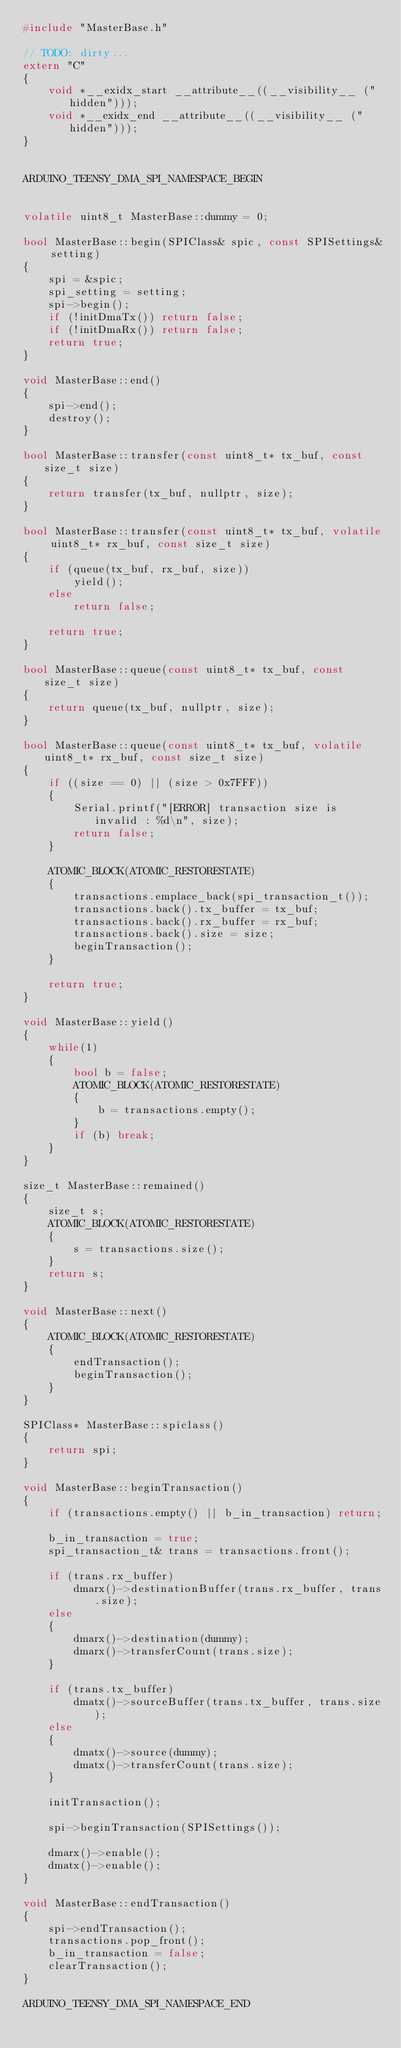Convert code to text. <code><loc_0><loc_0><loc_500><loc_500><_C++_>#include "MasterBase.h"

// TODO: dirty...
extern "C"
{
    void *__exidx_start __attribute__((__visibility__ ("hidden")));
    void *__exidx_end __attribute__((__visibility__ ("hidden")));
}


ARDUINO_TEENSY_DMA_SPI_NAMESPACE_BEGIN


volatile uint8_t MasterBase::dummy = 0;

bool MasterBase::begin(SPIClass& spic, const SPISettings& setting)
{
    spi = &spic;
    spi_setting = setting;
    spi->begin();
    if (!initDmaTx()) return false;
    if (!initDmaRx()) return false;
    return true;
}

void MasterBase::end()
{
    spi->end();
    destroy();
}

bool MasterBase::transfer(const uint8_t* tx_buf, const size_t size)
{
    return transfer(tx_buf, nullptr, size);
}

bool MasterBase::transfer(const uint8_t* tx_buf, volatile uint8_t* rx_buf, const size_t size)
{
    if (queue(tx_buf, rx_buf, size))
        yield();
    else
        return false;

    return true;
}

bool MasterBase::queue(const uint8_t* tx_buf, const size_t size)
{
    return queue(tx_buf, nullptr, size);
}

bool MasterBase::queue(const uint8_t* tx_buf, volatile uint8_t* rx_buf, const size_t size)
{
    if ((size == 0) || (size > 0x7FFF))
    {
        Serial.printf("[ERROR] transaction size is invalid : %d\n", size);
        return false;
    }

    ATOMIC_BLOCK(ATOMIC_RESTORESTATE)
    {
        transactions.emplace_back(spi_transaction_t());
        transactions.back().tx_buffer = tx_buf;
        transactions.back().rx_buffer = rx_buf;
        transactions.back().size = size;
        beginTransaction();
    }

    return true;
}

void MasterBase::yield()
{
    while(1)
    {
        bool b = false;
        ATOMIC_BLOCK(ATOMIC_RESTORESTATE)
        {
            b = transactions.empty();
        }
        if (b) break;
    }
}

size_t MasterBase::remained()
{
    size_t s;
    ATOMIC_BLOCK(ATOMIC_RESTORESTATE)
    {
        s = transactions.size();
    }
    return s;
}

void MasterBase::next()
{
    ATOMIC_BLOCK(ATOMIC_RESTORESTATE)
    {
        endTransaction();
        beginTransaction();
    }
}

SPIClass* MasterBase::spiclass()
{
    return spi;
}

void MasterBase::beginTransaction()
{
    if (transactions.empty() || b_in_transaction) return;

    b_in_transaction = true;
    spi_transaction_t& trans = transactions.front();

    if (trans.rx_buffer)
        dmarx()->destinationBuffer(trans.rx_buffer, trans.size);
    else
    {
        dmarx()->destination(dummy);
        dmarx()->transferCount(trans.size);
    }

    if (trans.tx_buffer)
        dmatx()->sourceBuffer(trans.tx_buffer, trans.size);
    else
    {
        dmatx()->source(dummy);
        dmatx()->transferCount(trans.size);
    }

    initTransaction();

    spi->beginTransaction(SPISettings());

    dmarx()->enable();
    dmatx()->enable();
}

void MasterBase::endTransaction()
{
    spi->endTransaction();
    transactions.pop_front();
    b_in_transaction = false;
    clearTransaction();
}

ARDUINO_TEENSY_DMA_SPI_NAMESPACE_END

</code> 